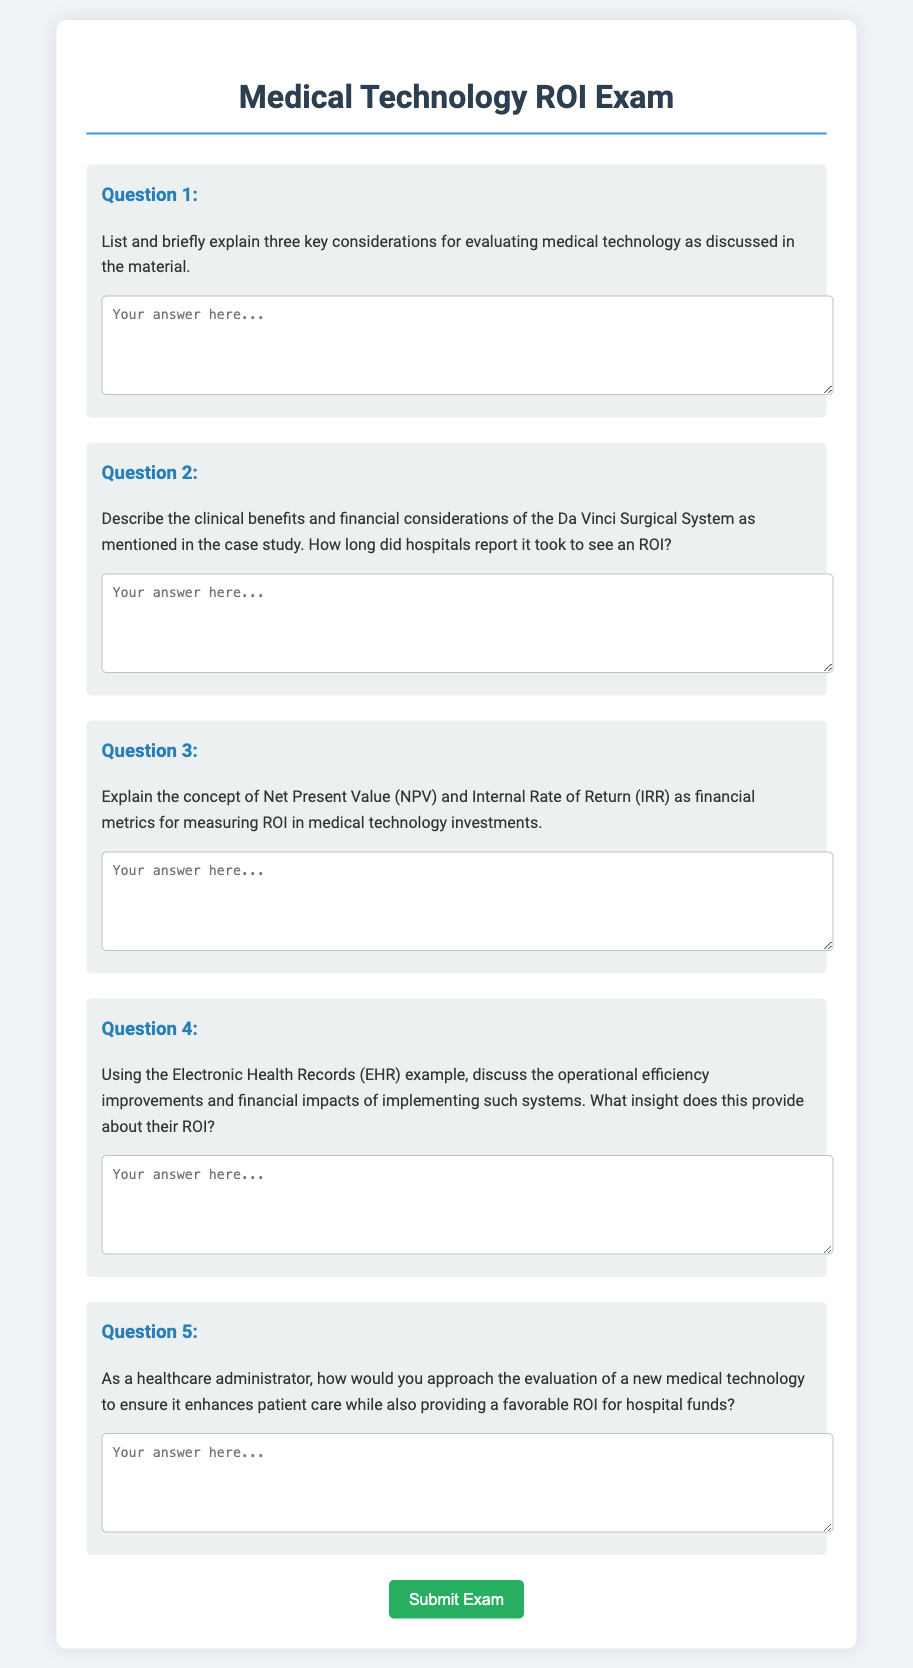What is the title of the exam? The title of the exam is prominently displayed at the top of the document.
Answer: Medical Technology ROI Exam How many questions are in the exam? The document lists a total of five questions for respondents to answer.
Answer: 5 What is the color of the submit button? The submit button is described in the styling section of the document with a specific background color.
Answer: Green What is the placeholder text in the first question's textarea? The textarea for the first question contains placeholder text guiding the user on what to type.
Answer: Your answer here.. What does NPV stand for? The acronym NPV is mentioned as a financial metric in the context of measuring ROI.
Answer: Net Present Value According to the material, what is the clinical benefit of the Da Vinci Surgical System? The question specifically pertains to the clinical benefits outlined in the case study.
Answer: Minimally invasive surgery What insight does implementing Electronic Health Records provide about ROI? The financial impacts and improvements in operational efficiency from EHR systems offer crucial insight into ROI.
Answer: Favorable ROI What financial consideration is associated with the Da Vinci Surgical System? Financial considerations as described in the case study involve costs associated with the technology.
Answer: Cost-effectiveness What is the purpose of the submit button? The submit button is designed for respondents to finalize their exam submission.
Answer: Submit Exam 